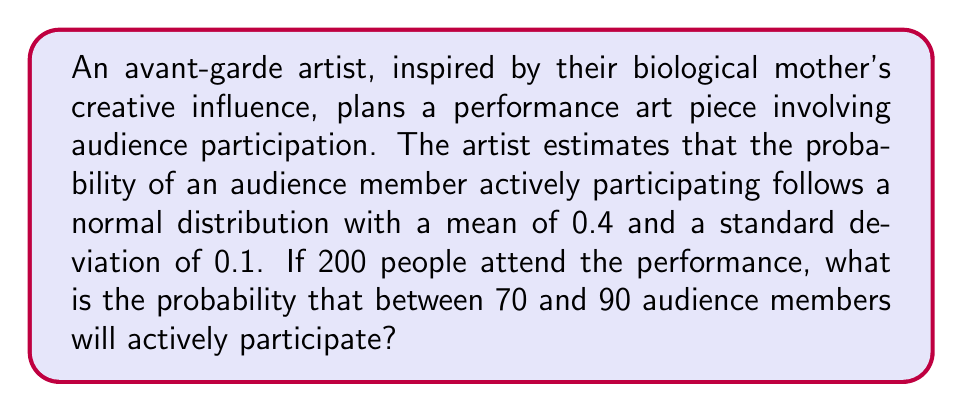Can you solve this math problem? Let's approach this step-by-step:

1) Let X be the number of audience members who actively participate. X follows a binomial distribution with n = 200 and p = 0.4.

2) Since n is large (>30) and np = 200 * 0.4 = 80 > 5, we can approximate this binomial distribution with a normal distribution.

3) The mean of this normal distribution is:
   $$\mu = np = 200 * 0.4 = 80$$

4) The standard deviation is:
   $$\sigma = \sqrt{np(1-p)} = \sqrt{200 * 0.4 * 0.6} = \sqrt{48} \approx 6.93$$

5) We need to find P(70 ≤ X ≤ 90). To use the standard normal distribution, we need to standardize these values:

   $$z_{1} = \frac{70 - 80}{6.93} \approx -1.44$$
   $$z_{2} = \frac{90 - 80}{6.93} \approx 1.44$$

6) Now we need to find P(-1.44 ≤ Z ≤ 1.44), where Z is a standard normal variable.

7) Using the standard normal table or a calculator:
   P(Z ≤ 1.44) ≈ 0.9251
   P(Z ≤ -1.44) ≈ 0.0749

8) Therefore, P(-1.44 ≤ Z ≤ 1.44) = 0.9251 - 0.0749 = 0.8502

Thus, the probability that between 70 and 90 audience members will actively participate is approximately 0.8502 or 85.02%.
Answer: 0.8502 